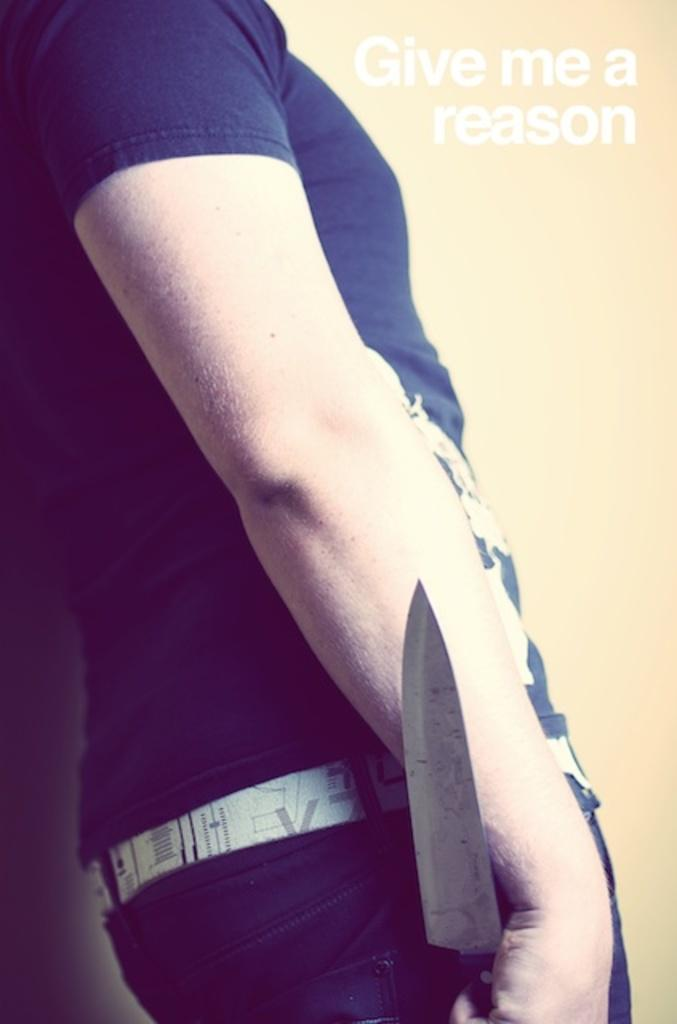Who or what is present in the image? There is a person in the image. What is the person holding in their hand? The person is holding a knife in their hand. Can you describe the person's clothing? The person is wearing a t-shirt and pants. Is there any additional information about the image? Yes, there is a watermark in the image. What type of leaf is being used as a trampoline by the person in the image? There is no leaf or trampoline present in the image; the person is holding a knife and wearing a t-shirt and pants. 